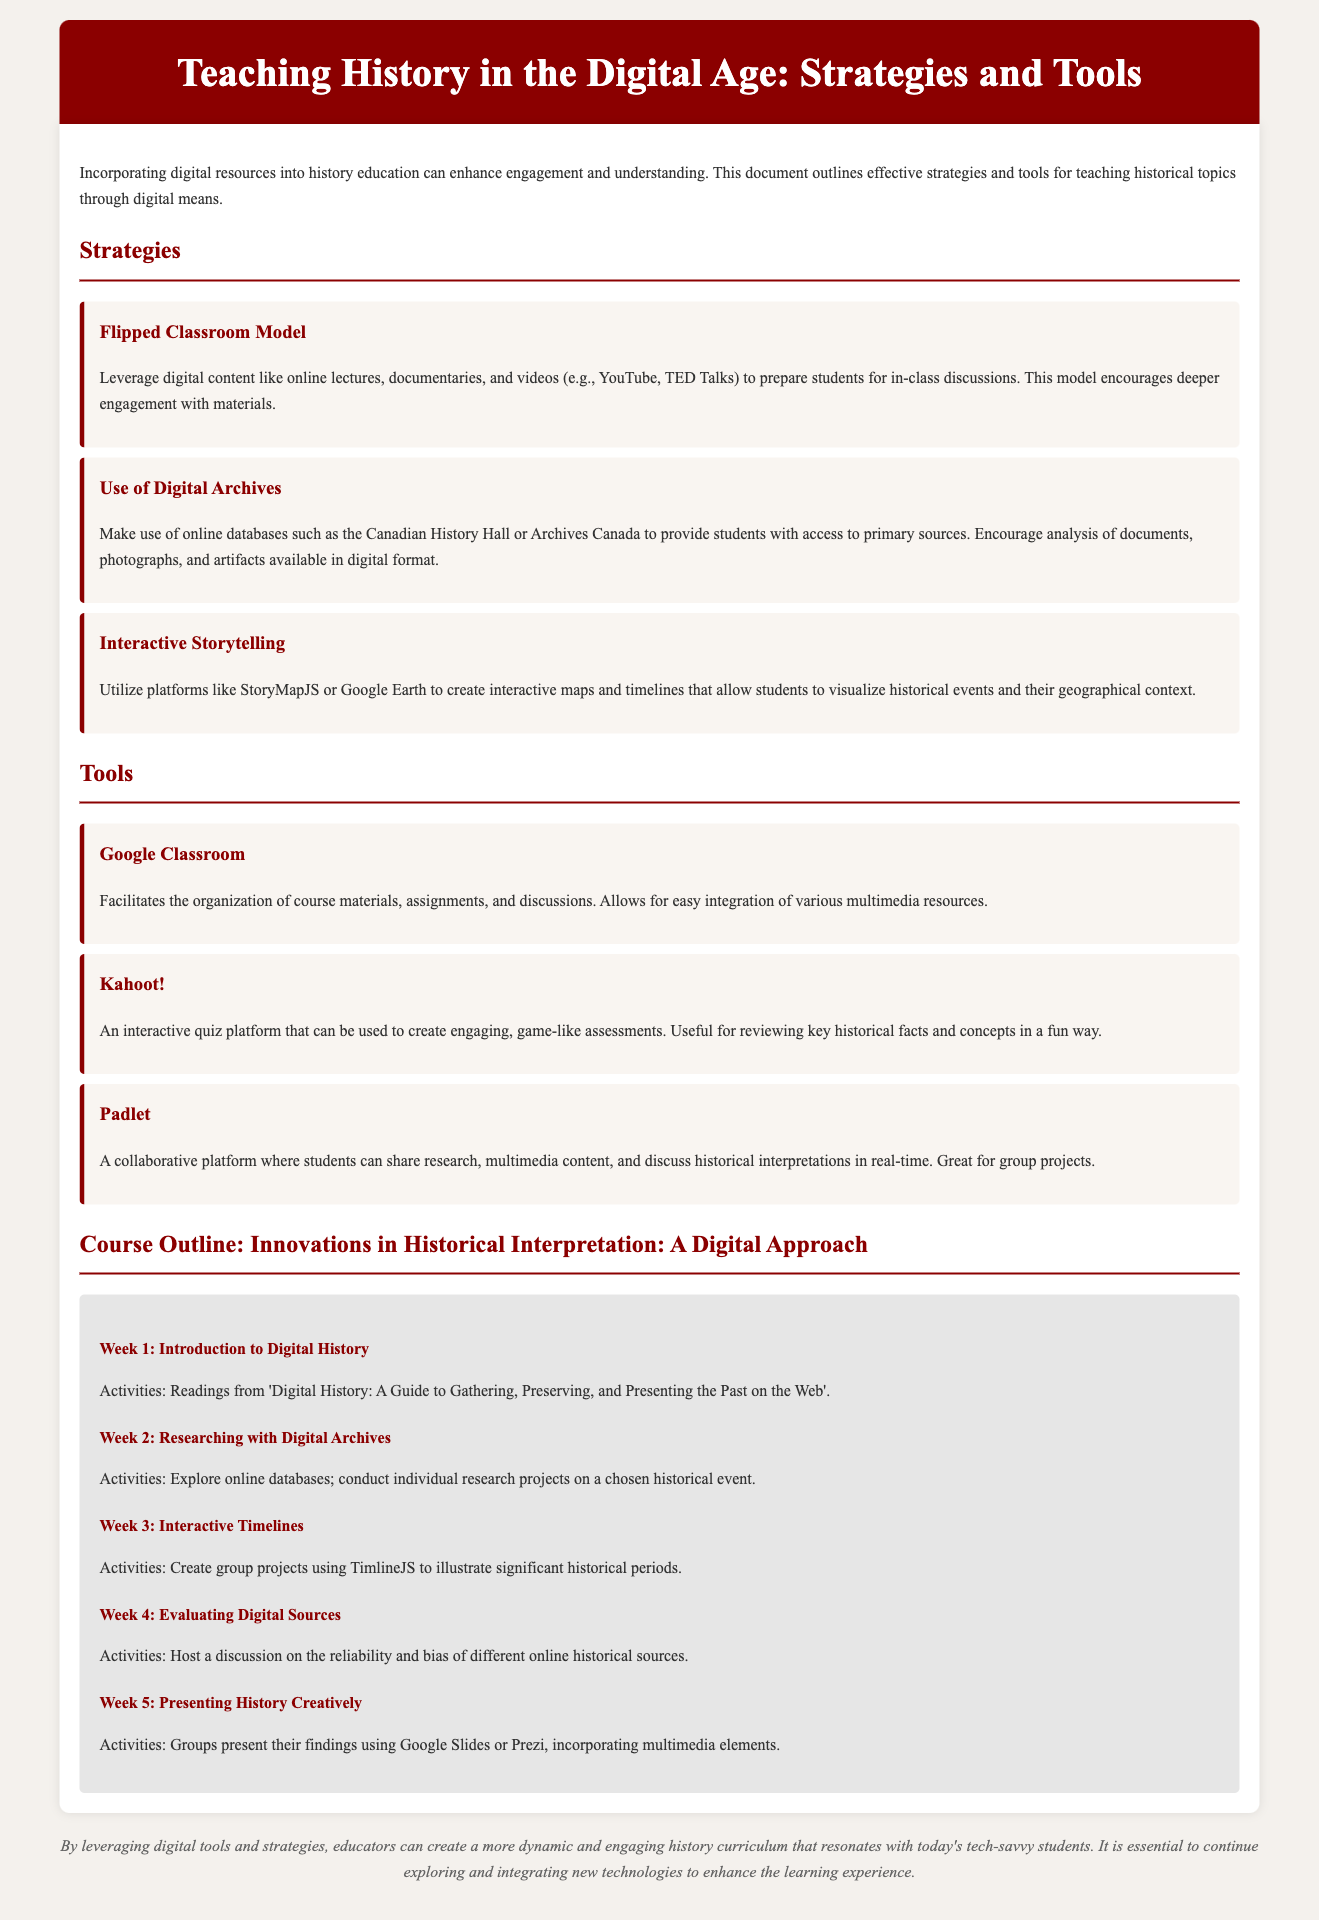What is the title of the document? The title is found in the header of the document, introducing the main topic discussed.
Answer: Teaching History in the Digital Age: Strategies and Tools Name one strategy mentioned for teaching history. The document outlines several strategies in the Strategies section.
Answer: Flipped Classroom Model Which tool is described as a collaborative platform? The Tools section lists various tools, specifying their uses in teaching history.
Answer: Padlet How many weeks are covered in the course outline? The Course Outline section details the number of weeks included in the course structure.
Answer: Five What is the focus of Week 4 in the course outline? Each week has a specific topic detailed, indicating its focus.
Answer: Evaluating Digital Sources List one multimedia platform suggested for presenting findings. The document suggests various multimedia tools for presentations in the Activities section.
Answer: Google Slides Which strategy encourages students to analyze primary sources? The Strategies section provides various methods for engaging with historical content.
Answer: Use of Digital Archives What does Kahoot! facilitate? The Tools section explains the purpose of each tool in an educational context.
Answer: Engaging, game-like assessments 